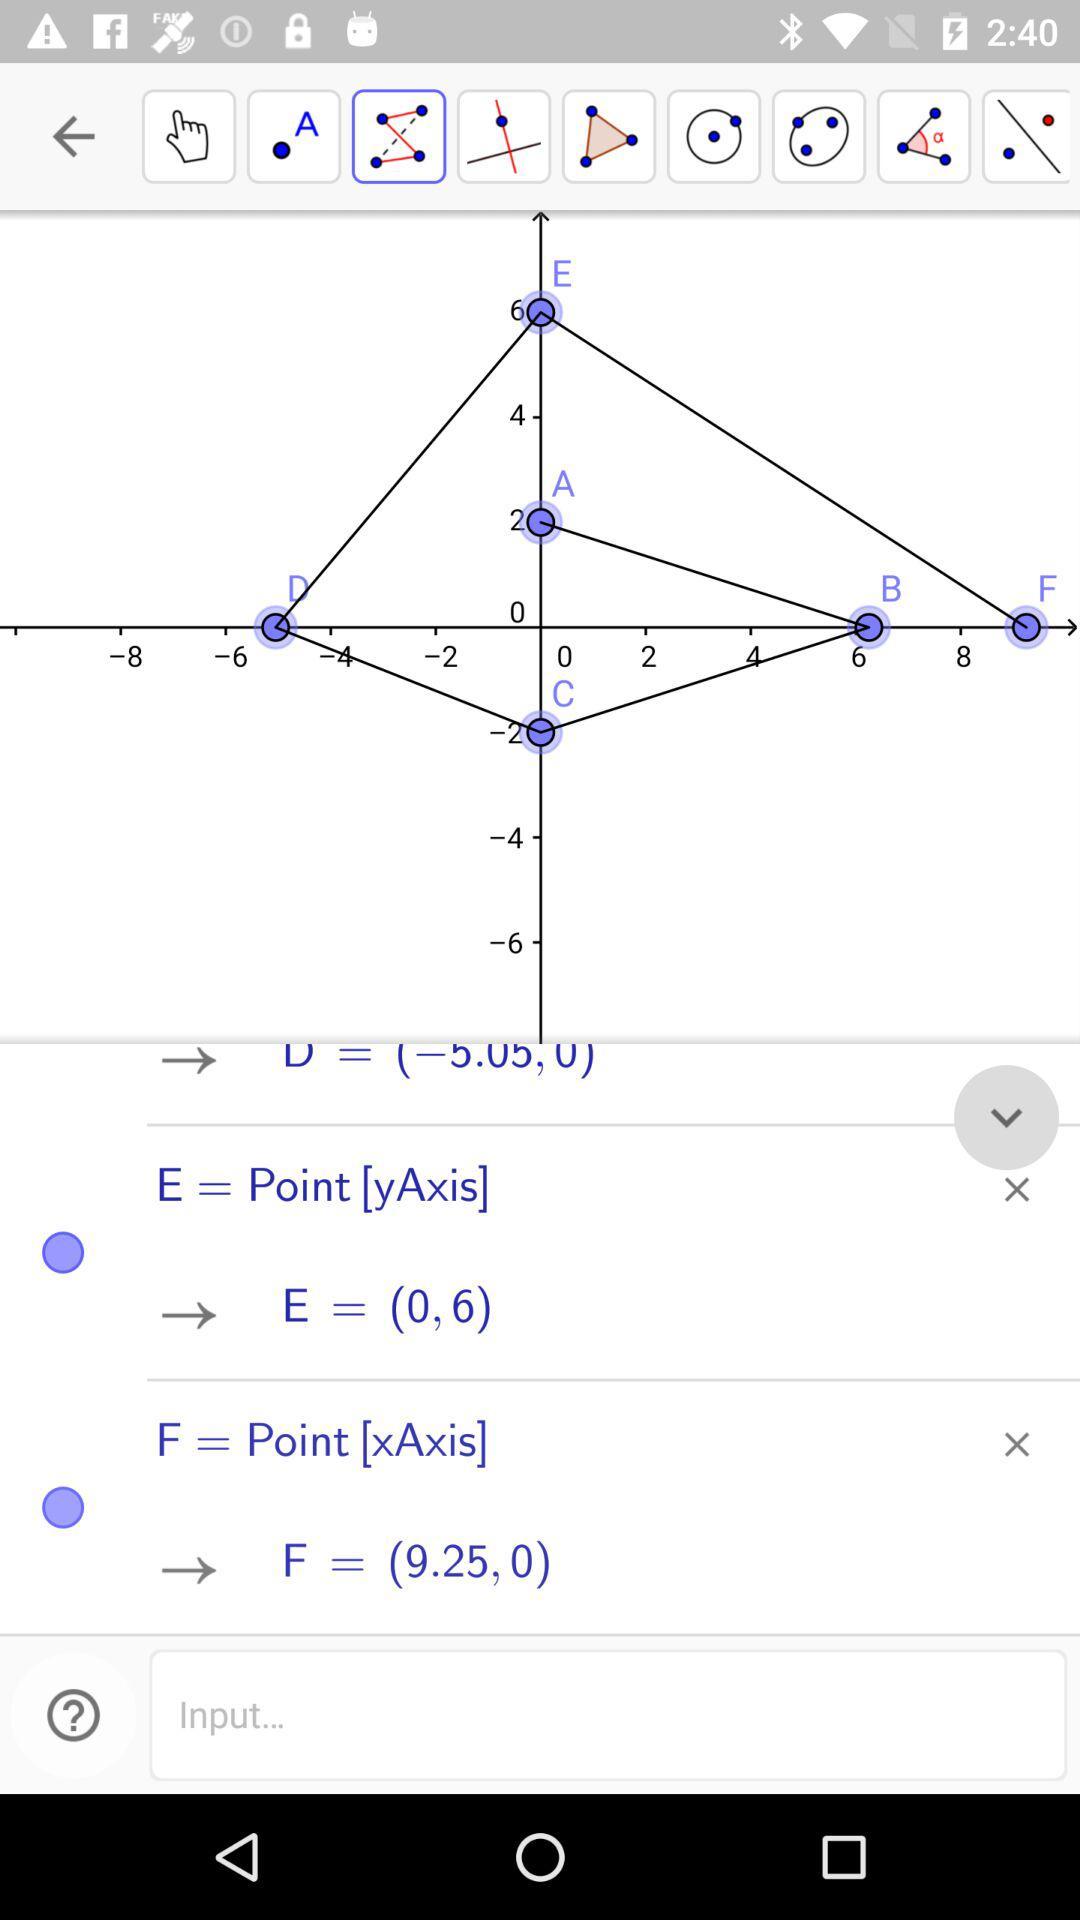On which axis is the E point? The E point is on the y-axis. 